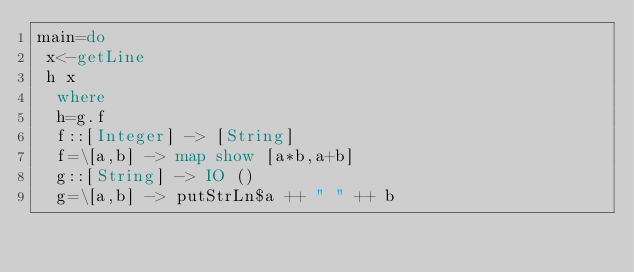Convert code to text. <code><loc_0><loc_0><loc_500><loc_500><_Haskell_>main=do
 x<-getLine
 h x
  where
  h=g.f
  f::[Integer] -> [String]
  f=\[a,b] -> map show [a*b,a+b]
  g::[String] -> IO ()
  g=\[a,b] -> putStrLn$a ++ " " ++ b</code> 